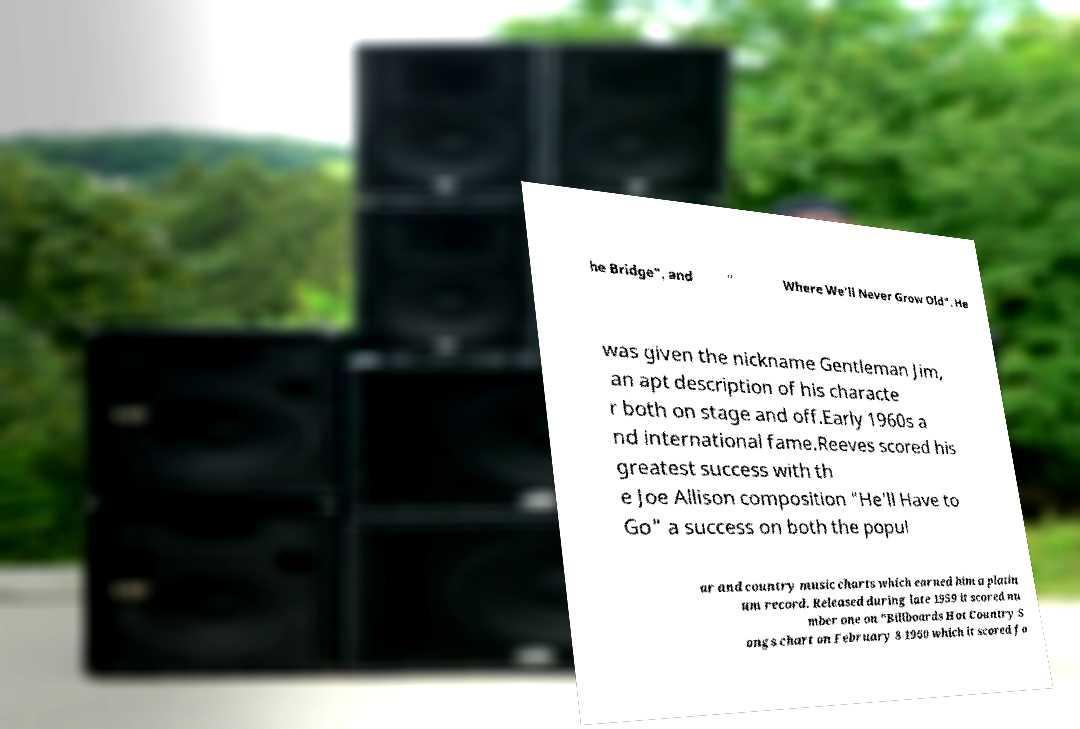Could you assist in decoding the text presented in this image and type it out clearly? he Bridge", and " Where We'll Never Grow Old". He was given the nickname Gentleman Jim, an apt description of his characte r both on stage and off.Early 1960s a nd international fame.Reeves scored his greatest success with th e Joe Allison composition "He'll Have to Go" a success on both the popul ar and country music charts which earned him a platin um record. Released during late 1959 it scored nu mber one on "Billboards Hot Country S ongs chart on February 8 1960 which it scored fo 